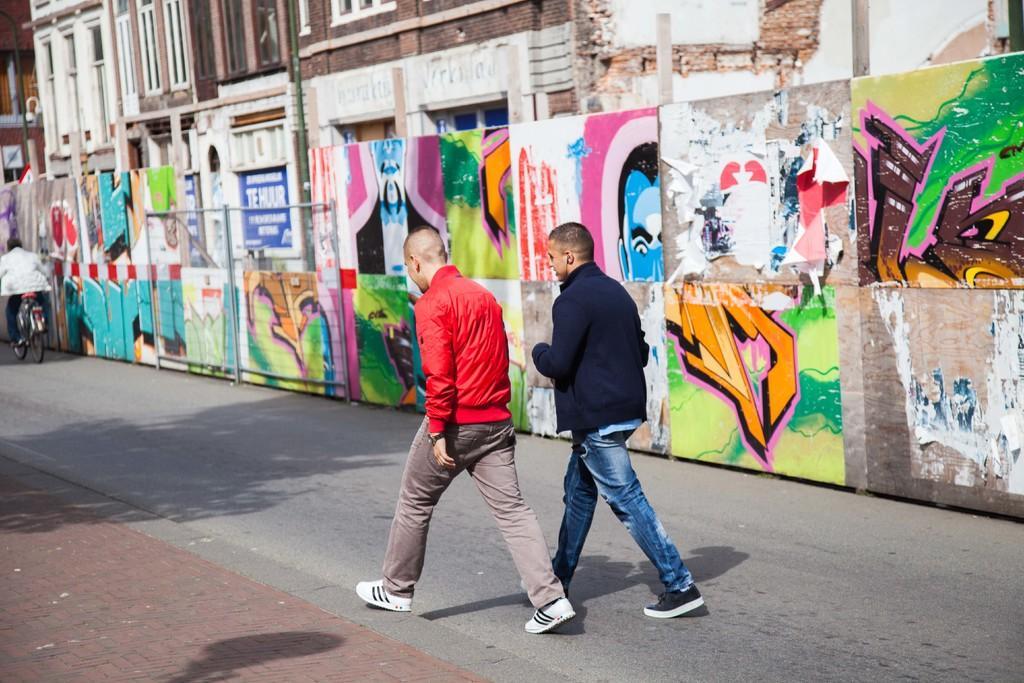Could you give a brief overview of what you see in this image? In this image I can see two people walking on the road. On the left side I can see a person sitting on the bicycle. In the background, I can see a wall and a building. 